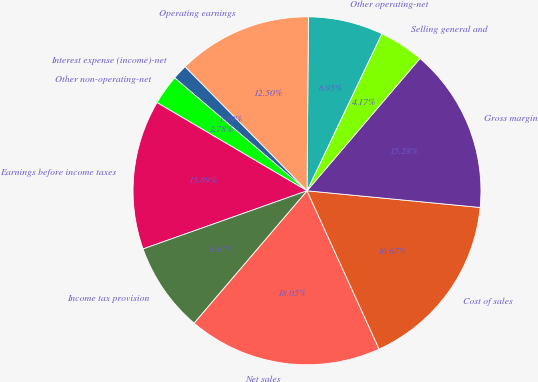<chart> <loc_0><loc_0><loc_500><loc_500><pie_chart><fcel>Net sales<fcel>Cost of sales<fcel>Gross margin<fcel>Selling general and<fcel>Other operating-net<fcel>Operating earnings<fcel>Interest expense (income)-net<fcel>Other non-operating-net<fcel>Earnings before income taxes<fcel>Income tax provision<nl><fcel>18.05%<fcel>16.67%<fcel>15.28%<fcel>4.17%<fcel>6.95%<fcel>12.5%<fcel>1.39%<fcel>2.78%<fcel>13.89%<fcel>8.33%<nl></chart> 